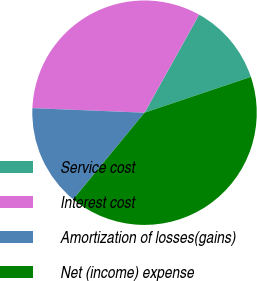Convert chart. <chart><loc_0><loc_0><loc_500><loc_500><pie_chart><fcel>Service cost<fcel>Interest cost<fcel>Amortization of losses(gains)<fcel>Net (income) expense<nl><fcel>11.74%<fcel>32.44%<fcel>14.68%<fcel>41.13%<nl></chart> 